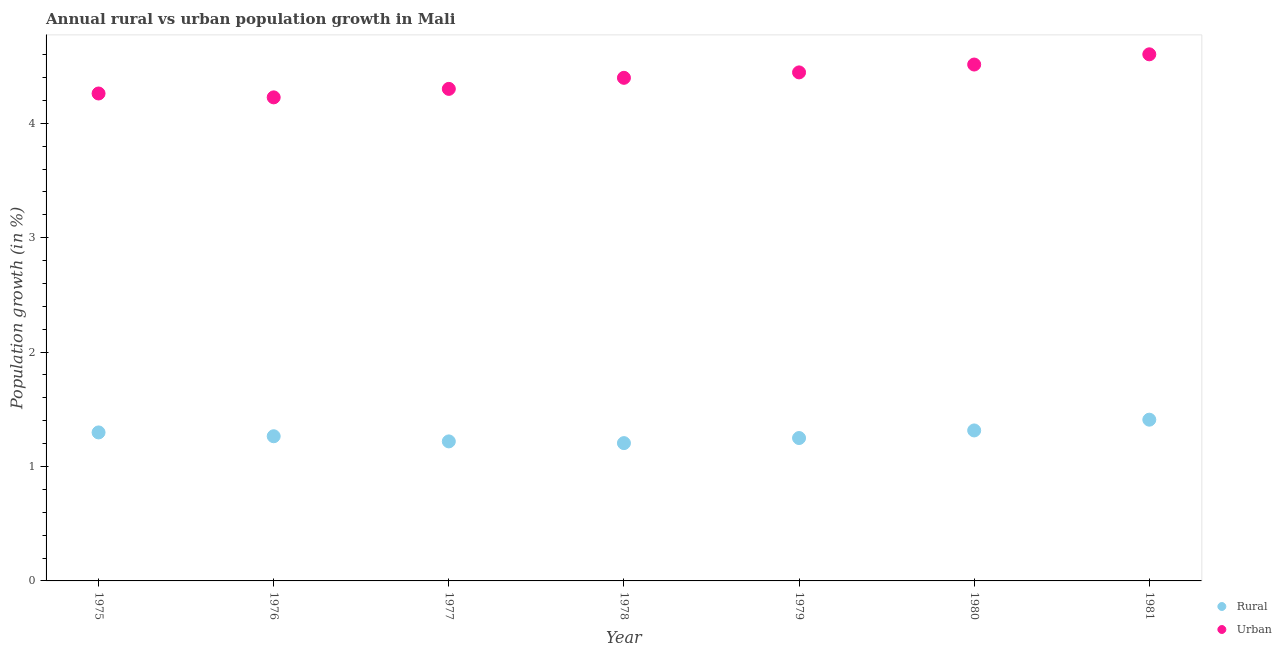How many different coloured dotlines are there?
Give a very brief answer. 2. What is the urban population growth in 1975?
Ensure brevity in your answer.  4.26. Across all years, what is the maximum rural population growth?
Ensure brevity in your answer.  1.41. Across all years, what is the minimum rural population growth?
Give a very brief answer. 1.2. In which year was the urban population growth minimum?
Your answer should be compact. 1976. What is the total rural population growth in the graph?
Keep it short and to the point. 8.96. What is the difference between the rural population growth in 1975 and that in 1979?
Your response must be concise. 0.05. What is the difference between the rural population growth in 1979 and the urban population growth in 1980?
Provide a succinct answer. -3.26. What is the average urban population growth per year?
Offer a very short reply. 4.39. In the year 1976, what is the difference between the rural population growth and urban population growth?
Your response must be concise. -2.96. What is the ratio of the urban population growth in 1978 to that in 1981?
Provide a short and direct response. 0.96. Is the rural population growth in 1980 less than that in 1981?
Offer a very short reply. Yes. What is the difference between the highest and the second highest rural population growth?
Give a very brief answer. 0.09. What is the difference between the highest and the lowest urban population growth?
Offer a very short reply. 0.38. In how many years, is the rural population growth greater than the average rural population growth taken over all years?
Your response must be concise. 3. Is the sum of the rural population growth in 1979 and 1981 greater than the maximum urban population growth across all years?
Offer a terse response. No. How many years are there in the graph?
Keep it short and to the point. 7. Are the values on the major ticks of Y-axis written in scientific E-notation?
Provide a succinct answer. No. Does the graph contain grids?
Your response must be concise. No. How many legend labels are there?
Make the answer very short. 2. How are the legend labels stacked?
Your answer should be compact. Vertical. What is the title of the graph?
Your answer should be very brief. Annual rural vs urban population growth in Mali. Does "Birth rate" appear as one of the legend labels in the graph?
Give a very brief answer. No. What is the label or title of the X-axis?
Your answer should be very brief. Year. What is the label or title of the Y-axis?
Give a very brief answer. Population growth (in %). What is the Population growth (in %) of Rural in 1975?
Give a very brief answer. 1.3. What is the Population growth (in %) in Urban  in 1975?
Make the answer very short. 4.26. What is the Population growth (in %) of Rural in 1976?
Provide a short and direct response. 1.26. What is the Population growth (in %) in Urban  in 1976?
Provide a short and direct response. 4.23. What is the Population growth (in %) of Rural in 1977?
Provide a short and direct response. 1.22. What is the Population growth (in %) in Urban  in 1977?
Make the answer very short. 4.3. What is the Population growth (in %) of Rural in 1978?
Offer a very short reply. 1.2. What is the Population growth (in %) of Urban  in 1978?
Your response must be concise. 4.4. What is the Population growth (in %) of Rural in 1979?
Provide a short and direct response. 1.25. What is the Population growth (in %) in Urban  in 1979?
Your response must be concise. 4.44. What is the Population growth (in %) in Rural in 1980?
Provide a succinct answer. 1.32. What is the Population growth (in %) in Urban  in 1980?
Ensure brevity in your answer.  4.51. What is the Population growth (in %) in Rural in 1981?
Ensure brevity in your answer.  1.41. What is the Population growth (in %) of Urban  in 1981?
Ensure brevity in your answer.  4.6. Across all years, what is the maximum Population growth (in %) in Rural?
Provide a short and direct response. 1.41. Across all years, what is the maximum Population growth (in %) of Urban ?
Make the answer very short. 4.6. Across all years, what is the minimum Population growth (in %) in Rural?
Keep it short and to the point. 1.2. Across all years, what is the minimum Population growth (in %) in Urban ?
Offer a terse response. 4.23. What is the total Population growth (in %) in Rural in the graph?
Offer a very short reply. 8.96. What is the total Population growth (in %) in Urban  in the graph?
Keep it short and to the point. 30.74. What is the difference between the Population growth (in %) of Rural in 1975 and that in 1976?
Offer a terse response. 0.03. What is the difference between the Population growth (in %) of Urban  in 1975 and that in 1976?
Ensure brevity in your answer.  0.03. What is the difference between the Population growth (in %) of Rural in 1975 and that in 1977?
Offer a terse response. 0.08. What is the difference between the Population growth (in %) of Urban  in 1975 and that in 1977?
Your answer should be compact. -0.04. What is the difference between the Population growth (in %) in Rural in 1975 and that in 1978?
Keep it short and to the point. 0.09. What is the difference between the Population growth (in %) in Urban  in 1975 and that in 1978?
Your answer should be very brief. -0.14. What is the difference between the Population growth (in %) of Rural in 1975 and that in 1979?
Offer a very short reply. 0.05. What is the difference between the Population growth (in %) in Urban  in 1975 and that in 1979?
Offer a very short reply. -0.18. What is the difference between the Population growth (in %) in Rural in 1975 and that in 1980?
Your answer should be very brief. -0.02. What is the difference between the Population growth (in %) of Urban  in 1975 and that in 1980?
Your answer should be compact. -0.25. What is the difference between the Population growth (in %) of Rural in 1975 and that in 1981?
Your answer should be compact. -0.11. What is the difference between the Population growth (in %) in Urban  in 1975 and that in 1981?
Offer a terse response. -0.34. What is the difference between the Population growth (in %) in Rural in 1976 and that in 1977?
Ensure brevity in your answer.  0.04. What is the difference between the Population growth (in %) in Urban  in 1976 and that in 1977?
Provide a succinct answer. -0.07. What is the difference between the Population growth (in %) of Rural in 1976 and that in 1978?
Provide a succinct answer. 0.06. What is the difference between the Population growth (in %) of Urban  in 1976 and that in 1978?
Make the answer very short. -0.17. What is the difference between the Population growth (in %) of Rural in 1976 and that in 1979?
Give a very brief answer. 0.02. What is the difference between the Population growth (in %) in Urban  in 1976 and that in 1979?
Your answer should be very brief. -0.22. What is the difference between the Population growth (in %) of Rural in 1976 and that in 1980?
Offer a terse response. -0.05. What is the difference between the Population growth (in %) in Urban  in 1976 and that in 1980?
Offer a very short reply. -0.29. What is the difference between the Population growth (in %) in Rural in 1976 and that in 1981?
Ensure brevity in your answer.  -0.14. What is the difference between the Population growth (in %) of Urban  in 1976 and that in 1981?
Make the answer very short. -0.38. What is the difference between the Population growth (in %) of Rural in 1977 and that in 1978?
Your answer should be compact. 0.02. What is the difference between the Population growth (in %) of Urban  in 1977 and that in 1978?
Your answer should be very brief. -0.1. What is the difference between the Population growth (in %) of Rural in 1977 and that in 1979?
Keep it short and to the point. -0.03. What is the difference between the Population growth (in %) in Urban  in 1977 and that in 1979?
Provide a succinct answer. -0.14. What is the difference between the Population growth (in %) of Rural in 1977 and that in 1980?
Give a very brief answer. -0.1. What is the difference between the Population growth (in %) of Urban  in 1977 and that in 1980?
Provide a succinct answer. -0.21. What is the difference between the Population growth (in %) in Rural in 1977 and that in 1981?
Your answer should be very brief. -0.19. What is the difference between the Population growth (in %) of Urban  in 1977 and that in 1981?
Provide a succinct answer. -0.3. What is the difference between the Population growth (in %) in Rural in 1978 and that in 1979?
Your answer should be very brief. -0.04. What is the difference between the Population growth (in %) in Urban  in 1978 and that in 1979?
Ensure brevity in your answer.  -0.05. What is the difference between the Population growth (in %) in Rural in 1978 and that in 1980?
Offer a terse response. -0.11. What is the difference between the Population growth (in %) of Urban  in 1978 and that in 1980?
Offer a very short reply. -0.12. What is the difference between the Population growth (in %) in Rural in 1978 and that in 1981?
Keep it short and to the point. -0.2. What is the difference between the Population growth (in %) of Urban  in 1978 and that in 1981?
Your response must be concise. -0.21. What is the difference between the Population growth (in %) in Rural in 1979 and that in 1980?
Provide a succinct answer. -0.07. What is the difference between the Population growth (in %) in Urban  in 1979 and that in 1980?
Offer a terse response. -0.07. What is the difference between the Population growth (in %) of Rural in 1979 and that in 1981?
Your answer should be compact. -0.16. What is the difference between the Population growth (in %) of Urban  in 1979 and that in 1981?
Provide a short and direct response. -0.16. What is the difference between the Population growth (in %) of Rural in 1980 and that in 1981?
Give a very brief answer. -0.09. What is the difference between the Population growth (in %) in Urban  in 1980 and that in 1981?
Offer a very short reply. -0.09. What is the difference between the Population growth (in %) in Rural in 1975 and the Population growth (in %) in Urban  in 1976?
Ensure brevity in your answer.  -2.93. What is the difference between the Population growth (in %) in Rural in 1975 and the Population growth (in %) in Urban  in 1977?
Ensure brevity in your answer.  -3. What is the difference between the Population growth (in %) in Rural in 1975 and the Population growth (in %) in Urban  in 1978?
Your answer should be very brief. -3.1. What is the difference between the Population growth (in %) of Rural in 1975 and the Population growth (in %) of Urban  in 1979?
Provide a succinct answer. -3.15. What is the difference between the Population growth (in %) of Rural in 1975 and the Population growth (in %) of Urban  in 1980?
Your response must be concise. -3.22. What is the difference between the Population growth (in %) of Rural in 1975 and the Population growth (in %) of Urban  in 1981?
Your response must be concise. -3.3. What is the difference between the Population growth (in %) in Rural in 1976 and the Population growth (in %) in Urban  in 1977?
Keep it short and to the point. -3.04. What is the difference between the Population growth (in %) of Rural in 1976 and the Population growth (in %) of Urban  in 1978?
Keep it short and to the point. -3.13. What is the difference between the Population growth (in %) of Rural in 1976 and the Population growth (in %) of Urban  in 1979?
Your answer should be very brief. -3.18. What is the difference between the Population growth (in %) of Rural in 1976 and the Population growth (in %) of Urban  in 1980?
Give a very brief answer. -3.25. What is the difference between the Population growth (in %) of Rural in 1976 and the Population growth (in %) of Urban  in 1981?
Offer a very short reply. -3.34. What is the difference between the Population growth (in %) in Rural in 1977 and the Population growth (in %) in Urban  in 1978?
Ensure brevity in your answer.  -3.18. What is the difference between the Population growth (in %) in Rural in 1977 and the Population growth (in %) in Urban  in 1979?
Ensure brevity in your answer.  -3.23. What is the difference between the Population growth (in %) of Rural in 1977 and the Population growth (in %) of Urban  in 1980?
Offer a very short reply. -3.29. What is the difference between the Population growth (in %) in Rural in 1977 and the Population growth (in %) in Urban  in 1981?
Keep it short and to the point. -3.38. What is the difference between the Population growth (in %) of Rural in 1978 and the Population growth (in %) of Urban  in 1979?
Your answer should be compact. -3.24. What is the difference between the Population growth (in %) in Rural in 1978 and the Population growth (in %) in Urban  in 1980?
Give a very brief answer. -3.31. What is the difference between the Population growth (in %) in Rural in 1978 and the Population growth (in %) in Urban  in 1981?
Provide a short and direct response. -3.4. What is the difference between the Population growth (in %) in Rural in 1979 and the Population growth (in %) in Urban  in 1980?
Make the answer very short. -3.26. What is the difference between the Population growth (in %) in Rural in 1979 and the Population growth (in %) in Urban  in 1981?
Offer a very short reply. -3.35. What is the difference between the Population growth (in %) in Rural in 1980 and the Population growth (in %) in Urban  in 1981?
Provide a succinct answer. -3.29. What is the average Population growth (in %) of Rural per year?
Keep it short and to the point. 1.28. What is the average Population growth (in %) in Urban  per year?
Your answer should be compact. 4.39. In the year 1975, what is the difference between the Population growth (in %) of Rural and Population growth (in %) of Urban ?
Provide a succinct answer. -2.96. In the year 1976, what is the difference between the Population growth (in %) in Rural and Population growth (in %) in Urban ?
Your answer should be very brief. -2.96. In the year 1977, what is the difference between the Population growth (in %) in Rural and Population growth (in %) in Urban ?
Your answer should be compact. -3.08. In the year 1978, what is the difference between the Population growth (in %) in Rural and Population growth (in %) in Urban ?
Provide a short and direct response. -3.19. In the year 1979, what is the difference between the Population growth (in %) of Rural and Population growth (in %) of Urban ?
Offer a terse response. -3.2. In the year 1980, what is the difference between the Population growth (in %) of Rural and Population growth (in %) of Urban ?
Your answer should be very brief. -3.2. In the year 1981, what is the difference between the Population growth (in %) in Rural and Population growth (in %) in Urban ?
Provide a short and direct response. -3.19. What is the ratio of the Population growth (in %) of Rural in 1975 to that in 1976?
Provide a short and direct response. 1.03. What is the ratio of the Population growth (in %) in Urban  in 1975 to that in 1976?
Provide a succinct answer. 1.01. What is the ratio of the Population growth (in %) of Rural in 1975 to that in 1977?
Provide a succinct answer. 1.06. What is the ratio of the Population growth (in %) in Urban  in 1975 to that in 1977?
Ensure brevity in your answer.  0.99. What is the ratio of the Population growth (in %) of Rural in 1975 to that in 1978?
Offer a very short reply. 1.08. What is the ratio of the Population growth (in %) in Urban  in 1975 to that in 1978?
Give a very brief answer. 0.97. What is the ratio of the Population growth (in %) in Rural in 1975 to that in 1979?
Your response must be concise. 1.04. What is the ratio of the Population growth (in %) of Urban  in 1975 to that in 1979?
Make the answer very short. 0.96. What is the ratio of the Population growth (in %) in Urban  in 1975 to that in 1980?
Your answer should be compact. 0.94. What is the ratio of the Population growth (in %) of Rural in 1975 to that in 1981?
Your answer should be very brief. 0.92. What is the ratio of the Population growth (in %) of Urban  in 1975 to that in 1981?
Offer a terse response. 0.93. What is the ratio of the Population growth (in %) of Rural in 1976 to that in 1977?
Your answer should be compact. 1.04. What is the ratio of the Population growth (in %) in Urban  in 1976 to that in 1977?
Your answer should be very brief. 0.98. What is the ratio of the Population growth (in %) of Rural in 1976 to that in 1978?
Your answer should be very brief. 1.05. What is the ratio of the Population growth (in %) of Urban  in 1976 to that in 1978?
Ensure brevity in your answer.  0.96. What is the ratio of the Population growth (in %) of Rural in 1976 to that in 1979?
Give a very brief answer. 1.01. What is the ratio of the Population growth (in %) of Urban  in 1976 to that in 1979?
Your answer should be very brief. 0.95. What is the ratio of the Population growth (in %) of Rural in 1976 to that in 1980?
Ensure brevity in your answer.  0.96. What is the ratio of the Population growth (in %) of Urban  in 1976 to that in 1980?
Your response must be concise. 0.94. What is the ratio of the Population growth (in %) in Rural in 1976 to that in 1981?
Your answer should be very brief. 0.9. What is the ratio of the Population growth (in %) of Urban  in 1976 to that in 1981?
Offer a terse response. 0.92. What is the ratio of the Population growth (in %) of Rural in 1977 to that in 1978?
Make the answer very short. 1.01. What is the ratio of the Population growth (in %) in Urban  in 1977 to that in 1978?
Offer a very short reply. 0.98. What is the ratio of the Population growth (in %) of Rural in 1977 to that in 1979?
Your response must be concise. 0.98. What is the ratio of the Population growth (in %) of Urban  in 1977 to that in 1979?
Offer a very short reply. 0.97. What is the ratio of the Population growth (in %) in Rural in 1977 to that in 1980?
Offer a terse response. 0.93. What is the ratio of the Population growth (in %) in Urban  in 1977 to that in 1980?
Give a very brief answer. 0.95. What is the ratio of the Population growth (in %) of Rural in 1977 to that in 1981?
Make the answer very short. 0.87. What is the ratio of the Population growth (in %) in Urban  in 1977 to that in 1981?
Offer a very short reply. 0.93. What is the ratio of the Population growth (in %) of Rural in 1978 to that in 1979?
Make the answer very short. 0.96. What is the ratio of the Population growth (in %) of Urban  in 1978 to that in 1979?
Your response must be concise. 0.99. What is the ratio of the Population growth (in %) in Rural in 1978 to that in 1980?
Make the answer very short. 0.92. What is the ratio of the Population growth (in %) of Urban  in 1978 to that in 1980?
Offer a very short reply. 0.97. What is the ratio of the Population growth (in %) in Rural in 1978 to that in 1981?
Your answer should be very brief. 0.85. What is the ratio of the Population growth (in %) of Urban  in 1978 to that in 1981?
Your answer should be compact. 0.96. What is the ratio of the Population growth (in %) of Rural in 1979 to that in 1980?
Your answer should be compact. 0.95. What is the ratio of the Population growth (in %) of Urban  in 1979 to that in 1980?
Provide a short and direct response. 0.98. What is the ratio of the Population growth (in %) of Rural in 1979 to that in 1981?
Provide a succinct answer. 0.89. What is the ratio of the Population growth (in %) in Urban  in 1979 to that in 1981?
Your answer should be very brief. 0.97. What is the ratio of the Population growth (in %) of Rural in 1980 to that in 1981?
Keep it short and to the point. 0.93. What is the ratio of the Population growth (in %) in Urban  in 1980 to that in 1981?
Make the answer very short. 0.98. What is the difference between the highest and the second highest Population growth (in %) of Rural?
Offer a very short reply. 0.09. What is the difference between the highest and the second highest Population growth (in %) of Urban ?
Offer a terse response. 0.09. What is the difference between the highest and the lowest Population growth (in %) of Rural?
Your answer should be compact. 0.2. What is the difference between the highest and the lowest Population growth (in %) of Urban ?
Keep it short and to the point. 0.38. 